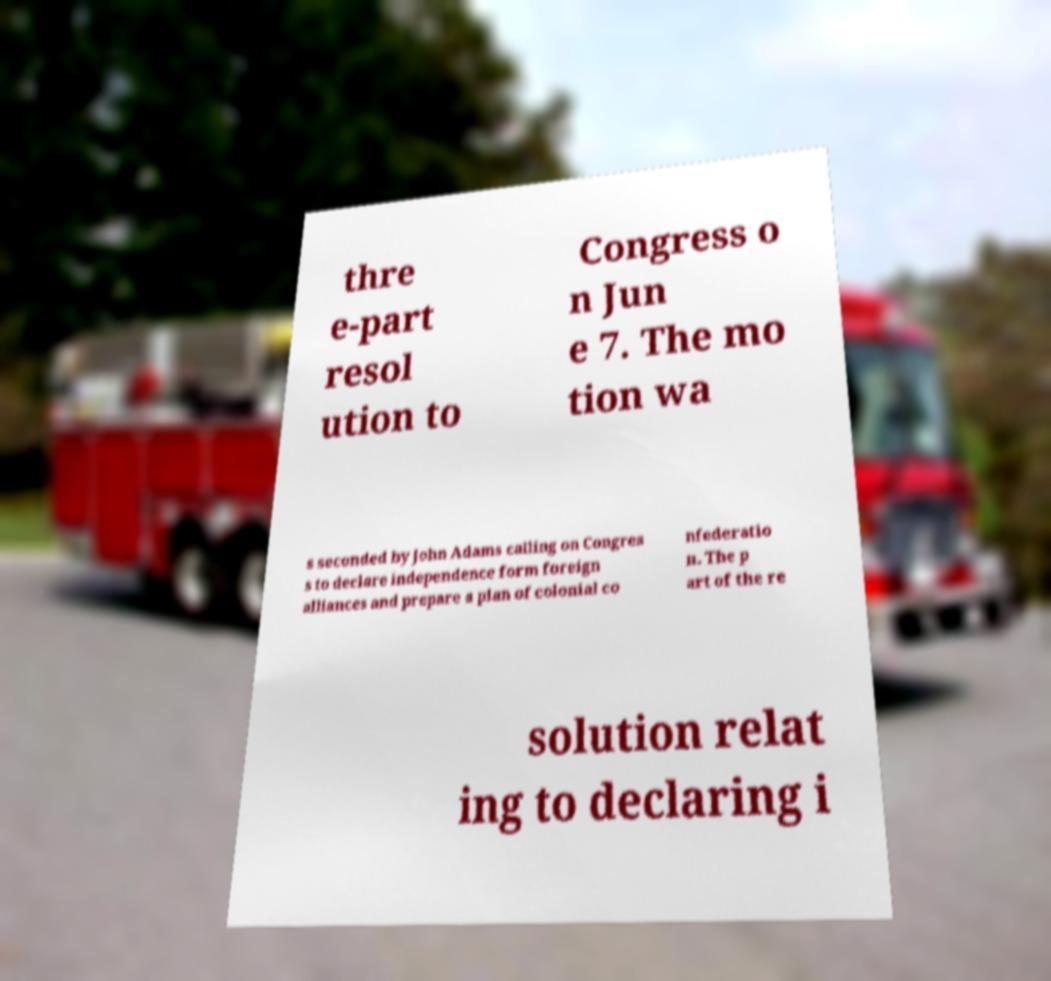Please identify and transcribe the text found in this image. thre e-part resol ution to Congress o n Jun e 7. The mo tion wa s seconded by John Adams calling on Congres s to declare independence form foreign alliances and prepare a plan of colonial co nfederatio n. The p art of the re solution relat ing to declaring i 